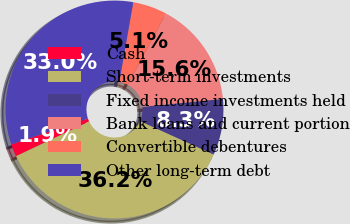<chart> <loc_0><loc_0><loc_500><loc_500><pie_chart><fcel>Cash<fcel>Short-term investments<fcel>Fixed income investments held<fcel>Bank loans and current portion<fcel>Convertible debentures<fcel>Other long-term debt<nl><fcel>1.85%<fcel>36.19%<fcel>8.32%<fcel>15.61%<fcel>5.08%<fcel>32.95%<nl></chart> 